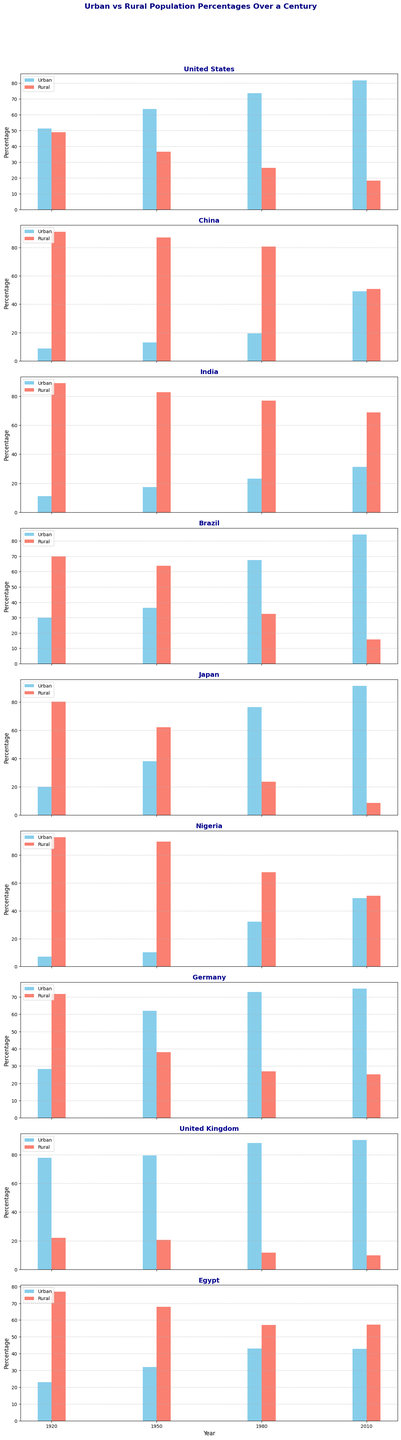What is the trend in the urban population percentage of the United States from 1920 to 2010? To determine the trend, look at the bars representing the urban population percentage of the United States for each year in the given interval. The height of the urban population bars increases steadily from 51.2% in 1920 to 81.8% in 2010, indicating a growing urban population trend over the century.
Answer: Increasing Which country had the highest urban population percentage in 2010? To find the country with the highest urban population percentage in 2010, compare the height of the urban population bars for that year across all countries. Japan had the highest urban population percentage at 91.3%, indicated by the tallest urban bar in 2010.
Answer: Japan Which country had the closest percentage of urban and rural populations in any given year? Look for the year and country where the urban and rural bars are most similar in height. In 2010, China had urban and rural populations very close, with urban at 49.2% and rural at 50.8%.
Answer: China in 2010 What is the difference in urban population percentages between Brazil in 1920 and 2010? Subtract the urban population percentage in 1920 from the percentage in 2010 for Brazil: 84.2% (2010) - 30.0% (1920) = 54.2%.
Answer: 54.2% Which country had the least increase in urban population percentage from 1920 to 2010? Calculate the increase for each country by subtracting the 1920 urban population percentage from the 2010 urban population percentage. Egypt had the least increase, with only 19.8% (42.8% - 23.0%).
Answer: Egypt How does the urban population percentage in Japan in 1980 compare to that in Nigeria in 2010? Compare the urban population percentages for Japan in 1980 and Nigeria in 2010 by looking at the height of the respective bars. Japan in 1980 had an urban population percentage of 76.4%, while Nigeria in 2010 had 49.1%. Japan’s urban population percentage was significantly higher.
Answer: Japan’s percentage was higher Which country showed the greatest reduction in rural population percentage from 1950 to 1980? Find the change in rural population percentage for each country by subtracting the 1980 percentage from the 1950 percentage. Brazil showed the greatest reduction: 63.7% (1950) - 32.5% (1980) = 31.2%.
Answer: Brazil What was the urban population percentage trend for Egypt from 1920 to 2010? Look at the urban population percentage bars for Egypt over the years. The trend shows an increase from 23.0% in 1920 to 42.8% in 2010, but with a slight dip between 1980 (43.0%) and 2010 (42.8%).
Answer: Increasing, slight dip between 1980 and 2010 How did the rural population percentage in China in 1950 compare to India in the same year? Compare the rural population percentages by looking at the height of the respective bars. In 1950, China had a rural population percentage of 87.0%, while India had 82.7%. China’s rural population percentage was higher.
Answer: China's percentage was higher 